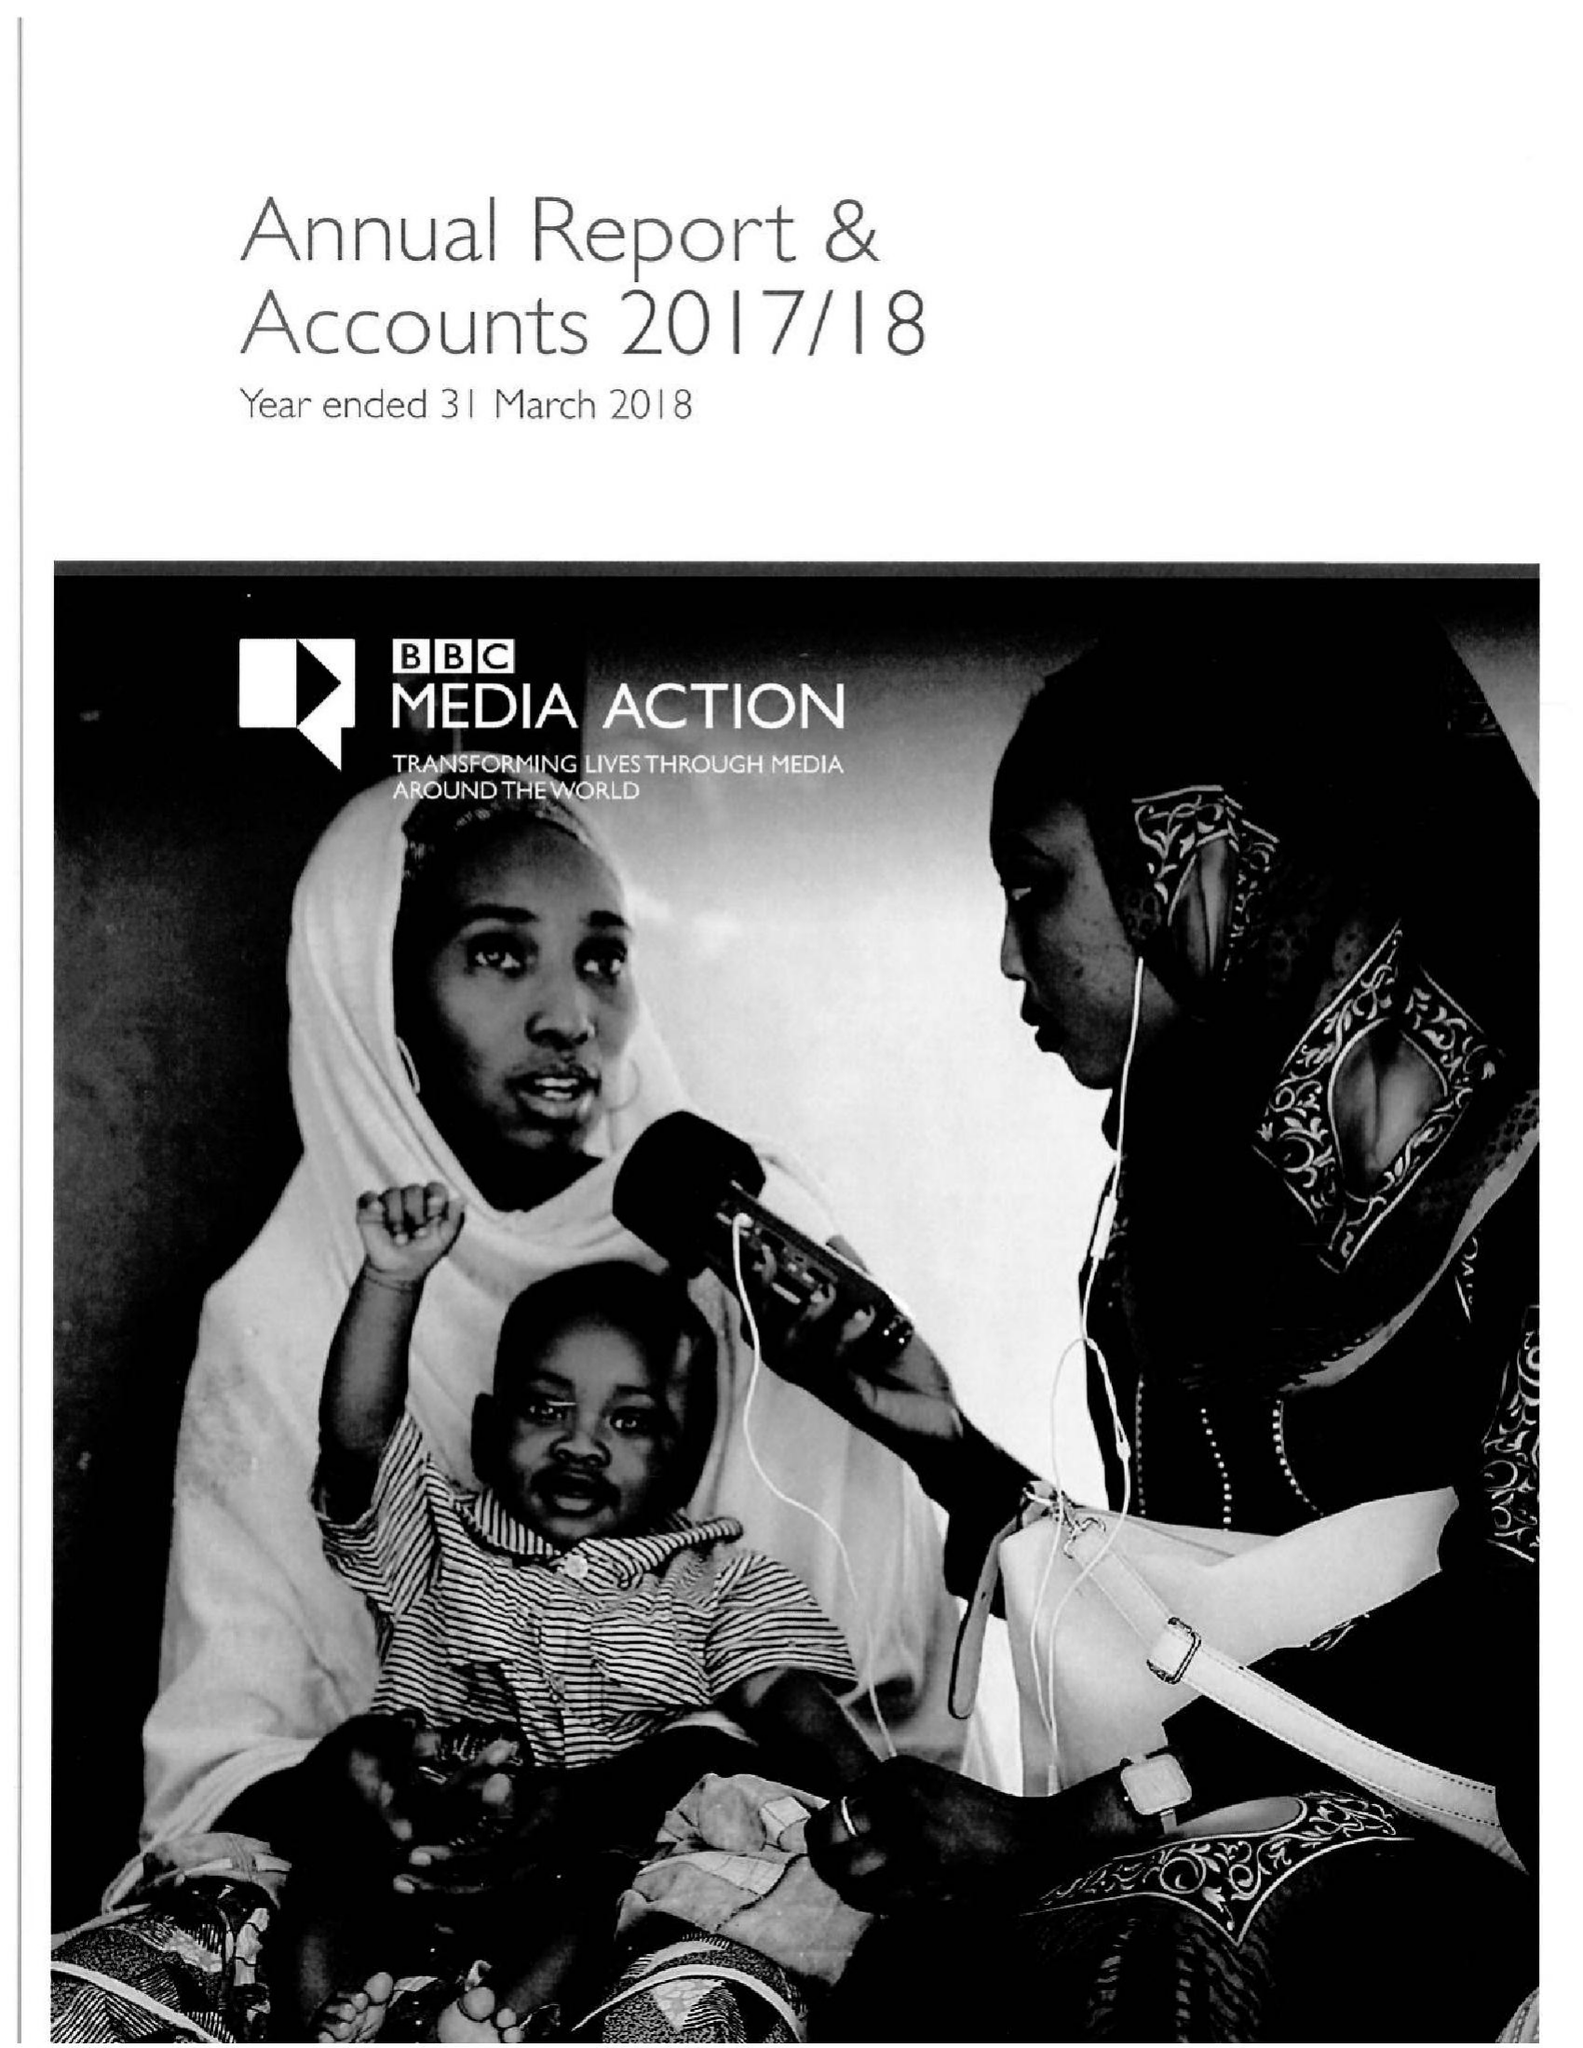What is the value for the report_date?
Answer the question using a single word or phrase. 2018-03-31 